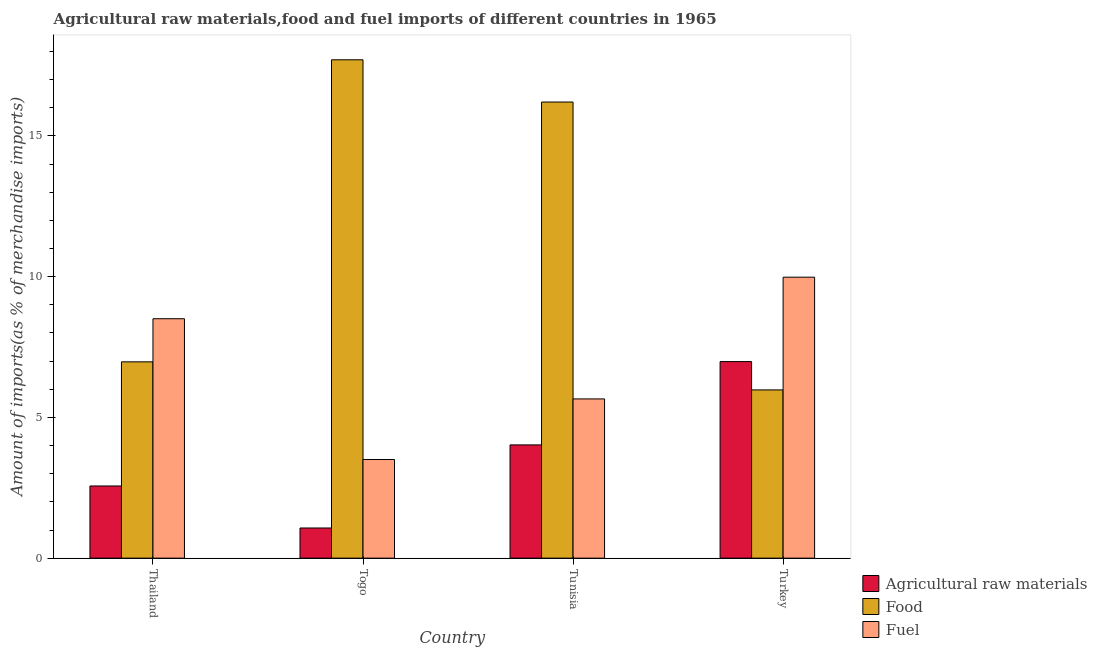How many groups of bars are there?
Provide a short and direct response. 4. Are the number of bars per tick equal to the number of legend labels?
Give a very brief answer. Yes. Are the number of bars on each tick of the X-axis equal?
Give a very brief answer. Yes. What is the label of the 3rd group of bars from the left?
Ensure brevity in your answer.  Tunisia. What is the percentage of food imports in Thailand?
Provide a succinct answer. 6.97. Across all countries, what is the maximum percentage of raw materials imports?
Provide a succinct answer. 6.98. Across all countries, what is the minimum percentage of raw materials imports?
Provide a short and direct response. 1.07. In which country was the percentage of raw materials imports maximum?
Provide a short and direct response. Turkey. In which country was the percentage of raw materials imports minimum?
Make the answer very short. Togo. What is the total percentage of fuel imports in the graph?
Give a very brief answer. 27.65. What is the difference between the percentage of fuel imports in Togo and that in Turkey?
Offer a very short reply. -6.48. What is the difference between the percentage of raw materials imports in Thailand and the percentage of fuel imports in Togo?
Provide a short and direct response. -0.94. What is the average percentage of food imports per country?
Offer a very short reply. 11.72. What is the difference between the percentage of raw materials imports and percentage of fuel imports in Turkey?
Your answer should be compact. -3. What is the ratio of the percentage of fuel imports in Thailand to that in Togo?
Provide a short and direct response. 2.43. What is the difference between the highest and the second highest percentage of fuel imports?
Provide a short and direct response. 1.48. What is the difference between the highest and the lowest percentage of raw materials imports?
Offer a very short reply. 5.91. In how many countries, is the percentage of raw materials imports greater than the average percentage of raw materials imports taken over all countries?
Your response must be concise. 2. Is the sum of the percentage of fuel imports in Thailand and Togo greater than the maximum percentage of raw materials imports across all countries?
Provide a short and direct response. Yes. What does the 1st bar from the left in Togo represents?
Keep it short and to the point. Agricultural raw materials. What does the 1st bar from the right in Turkey represents?
Offer a terse response. Fuel. Is it the case that in every country, the sum of the percentage of raw materials imports and percentage of food imports is greater than the percentage of fuel imports?
Your answer should be compact. Yes. How many bars are there?
Provide a short and direct response. 12. What is the difference between two consecutive major ticks on the Y-axis?
Your response must be concise. 5. Does the graph contain any zero values?
Give a very brief answer. No. Does the graph contain grids?
Ensure brevity in your answer.  No. What is the title of the graph?
Provide a short and direct response. Agricultural raw materials,food and fuel imports of different countries in 1965. Does "Gaseous fuel" appear as one of the legend labels in the graph?
Offer a very short reply. No. What is the label or title of the Y-axis?
Provide a succinct answer. Amount of imports(as % of merchandise imports). What is the Amount of imports(as % of merchandise imports) of Agricultural raw materials in Thailand?
Keep it short and to the point. 2.56. What is the Amount of imports(as % of merchandise imports) of Food in Thailand?
Your response must be concise. 6.97. What is the Amount of imports(as % of merchandise imports) in Fuel in Thailand?
Give a very brief answer. 8.51. What is the Amount of imports(as % of merchandise imports) of Agricultural raw materials in Togo?
Give a very brief answer. 1.07. What is the Amount of imports(as % of merchandise imports) in Food in Togo?
Provide a short and direct response. 17.71. What is the Amount of imports(as % of merchandise imports) of Fuel in Togo?
Keep it short and to the point. 3.5. What is the Amount of imports(as % of merchandise imports) in Agricultural raw materials in Tunisia?
Offer a terse response. 4.02. What is the Amount of imports(as % of merchandise imports) in Food in Tunisia?
Provide a succinct answer. 16.2. What is the Amount of imports(as % of merchandise imports) in Fuel in Tunisia?
Give a very brief answer. 5.66. What is the Amount of imports(as % of merchandise imports) of Agricultural raw materials in Turkey?
Give a very brief answer. 6.98. What is the Amount of imports(as % of merchandise imports) in Food in Turkey?
Your answer should be very brief. 5.98. What is the Amount of imports(as % of merchandise imports) of Fuel in Turkey?
Your response must be concise. 9.98. Across all countries, what is the maximum Amount of imports(as % of merchandise imports) in Agricultural raw materials?
Your answer should be very brief. 6.98. Across all countries, what is the maximum Amount of imports(as % of merchandise imports) in Food?
Provide a succinct answer. 17.71. Across all countries, what is the maximum Amount of imports(as % of merchandise imports) of Fuel?
Provide a short and direct response. 9.98. Across all countries, what is the minimum Amount of imports(as % of merchandise imports) in Agricultural raw materials?
Offer a terse response. 1.07. Across all countries, what is the minimum Amount of imports(as % of merchandise imports) in Food?
Give a very brief answer. 5.98. Across all countries, what is the minimum Amount of imports(as % of merchandise imports) of Fuel?
Your answer should be very brief. 3.5. What is the total Amount of imports(as % of merchandise imports) in Agricultural raw materials in the graph?
Provide a short and direct response. 14.64. What is the total Amount of imports(as % of merchandise imports) of Food in the graph?
Offer a very short reply. 46.86. What is the total Amount of imports(as % of merchandise imports) of Fuel in the graph?
Ensure brevity in your answer.  27.65. What is the difference between the Amount of imports(as % of merchandise imports) of Agricultural raw materials in Thailand and that in Togo?
Your answer should be compact. 1.49. What is the difference between the Amount of imports(as % of merchandise imports) in Food in Thailand and that in Togo?
Ensure brevity in your answer.  -10.73. What is the difference between the Amount of imports(as % of merchandise imports) of Fuel in Thailand and that in Togo?
Your response must be concise. 5. What is the difference between the Amount of imports(as % of merchandise imports) in Agricultural raw materials in Thailand and that in Tunisia?
Your response must be concise. -1.46. What is the difference between the Amount of imports(as % of merchandise imports) in Food in Thailand and that in Tunisia?
Provide a succinct answer. -9.23. What is the difference between the Amount of imports(as % of merchandise imports) in Fuel in Thailand and that in Tunisia?
Offer a very short reply. 2.85. What is the difference between the Amount of imports(as % of merchandise imports) in Agricultural raw materials in Thailand and that in Turkey?
Your response must be concise. -4.42. What is the difference between the Amount of imports(as % of merchandise imports) in Fuel in Thailand and that in Turkey?
Ensure brevity in your answer.  -1.48. What is the difference between the Amount of imports(as % of merchandise imports) in Agricultural raw materials in Togo and that in Tunisia?
Your answer should be very brief. -2.95. What is the difference between the Amount of imports(as % of merchandise imports) in Food in Togo and that in Tunisia?
Give a very brief answer. 1.5. What is the difference between the Amount of imports(as % of merchandise imports) of Fuel in Togo and that in Tunisia?
Provide a succinct answer. -2.15. What is the difference between the Amount of imports(as % of merchandise imports) in Agricultural raw materials in Togo and that in Turkey?
Keep it short and to the point. -5.91. What is the difference between the Amount of imports(as % of merchandise imports) of Food in Togo and that in Turkey?
Provide a short and direct response. 11.73. What is the difference between the Amount of imports(as % of merchandise imports) of Fuel in Togo and that in Turkey?
Offer a very short reply. -6.48. What is the difference between the Amount of imports(as % of merchandise imports) in Agricultural raw materials in Tunisia and that in Turkey?
Offer a terse response. -2.96. What is the difference between the Amount of imports(as % of merchandise imports) in Food in Tunisia and that in Turkey?
Your response must be concise. 10.23. What is the difference between the Amount of imports(as % of merchandise imports) of Fuel in Tunisia and that in Turkey?
Provide a short and direct response. -4.32. What is the difference between the Amount of imports(as % of merchandise imports) in Agricultural raw materials in Thailand and the Amount of imports(as % of merchandise imports) in Food in Togo?
Give a very brief answer. -15.14. What is the difference between the Amount of imports(as % of merchandise imports) in Agricultural raw materials in Thailand and the Amount of imports(as % of merchandise imports) in Fuel in Togo?
Your answer should be compact. -0.94. What is the difference between the Amount of imports(as % of merchandise imports) in Food in Thailand and the Amount of imports(as % of merchandise imports) in Fuel in Togo?
Offer a terse response. 3.47. What is the difference between the Amount of imports(as % of merchandise imports) in Agricultural raw materials in Thailand and the Amount of imports(as % of merchandise imports) in Food in Tunisia?
Make the answer very short. -13.64. What is the difference between the Amount of imports(as % of merchandise imports) in Agricultural raw materials in Thailand and the Amount of imports(as % of merchandise imports) in Fuel in Tunisia?
Make the answer very short. -3.09. What is the difference between the Amount of imports(as % of merchandise imports) of Food in Thailand and the Amount of imports(as % of merchandise imports) of Fuel in Tunisia?
Offer a terse response. 1.32. What is the difference between the Amount of imports(as % of merchandise imports) of Agricultural raw materials in Thailand and the Amount of imports(as % of merchandise imports) of Food in Turkey?
Provide a short and direct response. -3.41. What is the difference between the Amount of imports(as % of merchandise imports) of Agricultural raw materials in Thailand and the Amount of imports(as % of merchandise imports) of Fuel in Turkey?
Keep it short and to the point. -7.42. What is the difference between the Amount of imports(as % of merchandise imports) of Food in Thailand and the Amount of imports(as % of merchandise imports) of Fuel in Turkey?
Give a very brief answer. -3.01. What is the difference between the Amount of imports(as % of merchandise imports) of Agricultural raw materials in Togo and the Amount of imports(as % of merchandise imports) of Food in Tunisia?
Your response must be concise. -15.13. What is the difference between the Amount of imports(as % of merchandise imports) of Agricultural raw materials in Togo and the Amount of imports(as % of merchandise imports) of Fuel in Tunisia?
Your answer should be very brief. -4.59. What is the difference between the Amount of imports(as % of merchandise imports) of Food in Togo and the Amount of imports(as % of merchandise imports) of Fuel in Tunisia?
Provide a short and direct response. 12.05. What is the difference between the Amount of imports(as % of merchandise imports) of Agricultural raw materials in Togo and the Amount of imports(as % of merchandise imports) of Food in Turkey?
Keep it short and to the point. -4.91. What is the difference between the Amount of imports(as % of merchandise imports) in Agricultural raw materials in Togo and the Amount of imports(as % of merchandise imports) in Fuel in Turkey?
Provide a succinct answer. -8.91. What is the difference between the Amount of imports(as % of merchandise imports) in Food in Togo and the Amount of imports(as % of merchandise imports) in Fuel in Turkey?
Keep it short and to the point. 7.72. What is the difference between the Amount of imports(as % of merchandise imports) in Agricultural raw materials in Tunisia and the Amount of imports(as % of merchandise imports) in Food in Turkey?
Offer a very short reply. -1.95. What is the difference between the Amount of imports(as % of merchandise imports) of Agricultural raw materials in Tunisia and the Amount of imports(as % of merchandise imports) of Fuel in Turkey?
Ensure brevity in your answer.  -5.96. What is the difference between the Amount of imports(as % of merchandise imports) of Food in Tunisia and the Amount of imports(as % of merchandise imports) of Fuel in Turkey?
Keep it short and to the point. 6.22. What is the average Amount of imports(as % of merchandise imports) in Agricultural raw materials per country?
Provide a succinct answer. 3.66. What is the average Amount of imports(as % of merchandise imports) in Food per country?
Offer a very short reply. 11.71. What is the average Amount of imports(as % of merchandise imports) of Fuel per country?
Provide a succinct answer. 6.91. What is the difference between the Amount of imports(as % of merchandise imports) in Agricultural raw materials and Amount of imports(as % of merchandise imports) in Food in Thailand?
Offer a very short reply. -4.41. What is the difference between the Amount of imports(as % of merchandise imports) of Agricultural raw materials and Amount of imports(as % of merchandise imports) of Fuel in Thailand?
Ensure brevity in your answer.  -5.94. What is the difference between the Amount of imports(as % of merchandise imports) of Food and Amount of imports(as % of merchandise imports) of Fuel in Thailand?
Give a very brief answer. -1.53. What is the difference between the Amount of imports(as % of merchandise imports) in Agricultural raw materials and Amount of imports(as % of merchandise imports) in Food in Togo?
Offer a very short reply. -16.63. What is the difference between the Amount of imports(as % of merchandise imports) in Agricultural raw materials and Amount of imports(as % of merchandise imports) in Fuel in Togo?
Your response must be concise. -2.43. What is the difference between the Amount of imports(as % of merchandise imports) in Food and Amount of imports(as % of merchandise imports) in Fuel in Togo?
Give a very brief answer. 14.2. What is the difference between the Amount of imports(as % of merchandise imports) in Agricultural raw materials and Amount of imports(as % of merchandise imports) in Food in Tunisia?
Your answer should be compact. -12.18. What is the difference between the Amount of imports(as % of merchandise imports) of Agricultural raw materials and Amount of imports(as % of merchandise imports) of Fuel in Tunisia?
Offer a very short reply. -1.63. What is the difference between the Amount of imports(as % of merchandise imports) of Food and Amount of imports(as % of merchandise imports) of Fuel in Tunisia?
Your response must be concise. 10.55. What is the difference between the Amount of imports(as % of merchandise imports) of Agricultural raw materials and Amount of imports(as % of merchandise imports) of Food in Turkey?
Keep it short and to the point. 1.01. What is the difference between the Amount of imports(as % of merchandise imports) in Agricultural raw materials and Amount of imports(as % of merchandise imports) in Fuel in Turkey?
Keep it short and to the point. -3. What is the difference between the Amount of imports(as % of merchandise imports) of Food and Amount of imports(as % of merchandise imports) of Fuel in Turkey?
Your answer should be very brief. -4.01. What is the ratio of the Amount of imports(as % of merchandise imports) in Agricultural raw materials in Thailand to that in Togo?
Make the answer very short. 2.39. What is the ratio of the Amount of imports(as % of merchandise imports) of Food in Thailand to that in Togo?
Offer a very short reply. 0.39. What is the ratio of the Amount of imports(as % of merchandise imports) of Fuel in Thailand to that in Togo?
Your answer should be compact. 2.43. What is the ratio of the Amount of imports(as % of merchandise imports) in Agricultural raw materials in Thailand to that in Tunisia?
Make the answer very short. 0.64. What is the ratio of the Amount of imports(as % of merchandise imports) of Food in Thailand to that in Tunisia?
Offer a terse response. 0.43. What is the ratio of the Amount of imports(as % of merchandise imports) in Fuel in Thailand to that in Tunisia?
Your response must be concise. 1.5. What is the ratio of the Amount of imports(as % of merchandise imports) of Agricultural raw materials in Thailand to that in Turkey?
Your answer should be very brief. 0.37. What is the ratio of the Amount of imports(as % of merchandise imports) of Food in Thailand to that in Turkey?
Offer a terse response. 1.17. What is the ratio of the Amount of imports(as % of merchandise imports) in Fuel in Thailand to that in Turkey?
Keep it short and to the point. 0.85. What is the ratio of the Amount of imports(as % of merchandise imports) in Agricultural raw materials in Togo to that in Tunisia?
Provide a short and direct response. 0.27. What is the ratio of the Amount of imports(as % of merchandise imports) in Food in Togo to that in Tunisia?
Make the answer very short. 1.09. What is the ratio of the Amount of imports(as % of merchandise imports) of Fuel in Togo to that in Tunisia?
Your response must be concise. 0.62. What is the ratio of the Amount of imports(as % of merchandise imports) of Agricultural raw materials in Togo to that in Turkey?
Keep it short and to the point. 0.15. What is the ratio of the Amount of imports(as % of merchandise imports) of Food in Togo to that in Turkey?
Your answer should be compact. 2.96. What is the ratio of the Amount of imports(as % of merchandise imports) in Fuel in Togo to that in Turkey?
Provide a short and direct response. 0.35. What is the ratio of the Amount of imports(as % of merchandise imports) of Agricultural raw materials in Tunisia to that in Turkey?
Keep it short and to the point. 0.58. What is the ratio of the Amount of imports(as % of merchandise imports) in Food in Tunisia to that in Turkey?
Your answer should be compact. 2.71. What is the ratio of the Amount of imports(as % of merchandise imports) of Fuel in Tunisia to that in Turkey?
Your response must be concise. 0.57. What is the difference between the highest and the second highest Amount of imports(as % of merchandise imports) in Agricultural raw materials?
Provide a succinct answer. 2.96. What is the difference between the highest and the second highest Amount of imports(as % of merchandise imports) of Food?
Keep it short and to the point. 1.5. What is the difference between the highest and the second highest Amount of imports(as % of merchandise imports) of Fuel?
Make the answer very short. 1.48. What is the difference between the highest and the lowest Amount of imports(as % of merchandise imports) in Agricultural raw materials?
Provide a short and direct response. 5.91. What is the difference between the highest and the lowest Amount of imports(as % of merchandise imports) in Food?
Your answer should be compact. 11.73. What is the difference between the highest and the lowest Amount of imports(as % of merchandise imports) of Fuel?
Give a very brief answer. 6.48. 